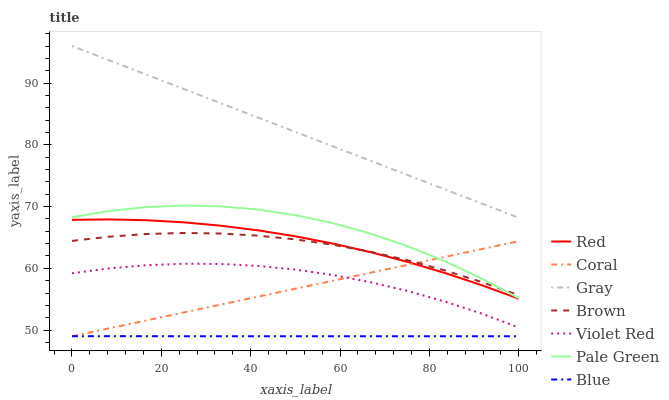Does Blue have the minimum area under the curve?
Answer yes or no. Yes. Does Gray have the maximum area under the curve?
Answer yes or no. Yes. Does Violet Red have the minimum area under the curve?
Answer yes or no. No. Does Violet Red have the maximum area under the curve?
Answer yes or no. No. Is Coral the smoothest?
Answer yes or no. Yes. Is Pale Green the roughest?
Answer yes or no. Yes. Is Gray the smoothest?
Answer yes or no. No. Is Gray the roughest?
Answer yes or no. No. Does Blue have the lowest value?
Answer yes or no. Yes. Does Violet Red have the lowest value?
Answer yes or no. No. Does Gray have the highest value?
Answer yes or no. Yes. Does Violet Red have the highest value?
Answer yes or no. No. Is Blue less than Brown?
Answer yes or no. Yes. Is Pale Green greater than Violet Red?
Answer yes or no. Yes. Does Coral intersect Violet Red?
Answer yes or no. Yes. Is Coral less than Violet Red?
Answer yes or no. No. Is Coral greater than Violet Red?
Answer yes or no. No. Does Blue intersect Brown?
Answer yes or no. No. 